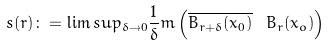Convert formula to latex. <formula><loc_0><loc_0><loc_500><loc_500>s ( r ) \colon = \lim s u p _ { \delta \to 0 } \frac { 1 } { \delta } m \left ( \overline { B _ { r + \delta } ( x _ { 0 } ) } \ B _ { r } ( x _ { o } ) \right )</formula> 